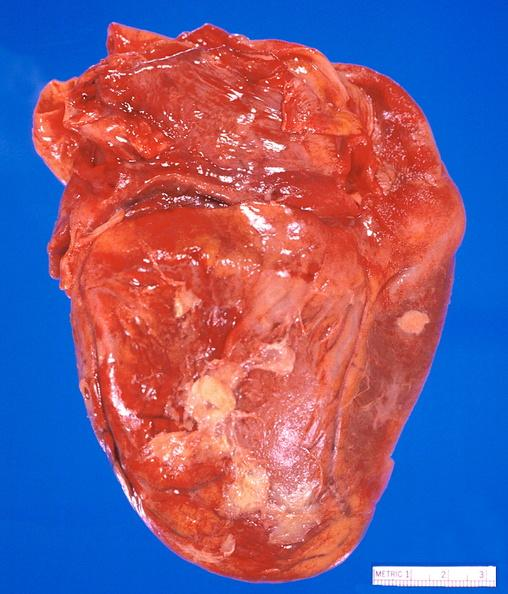does this image show heart, myocardial infarction free wall, 6 days old, in a patient with diabetes mellitus and hypertension?
Answer the question using a single word or phrase. Yes 